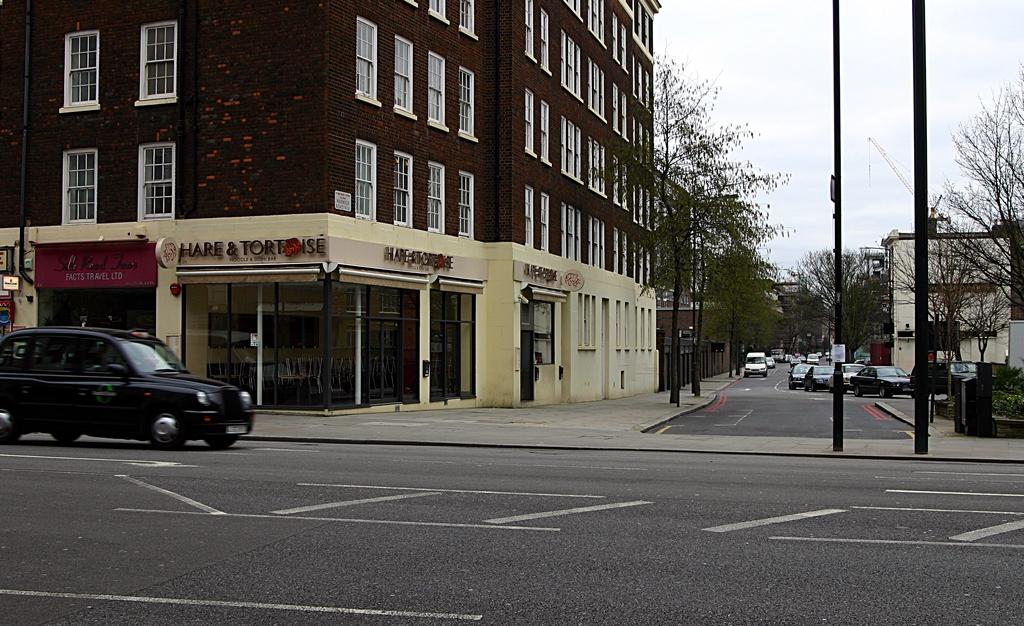The shop is called hare and what?
Provide a succinct answer. Tortoise. What does it say on the sign in red?
Your answer should be compact. Facts travel ltd. 